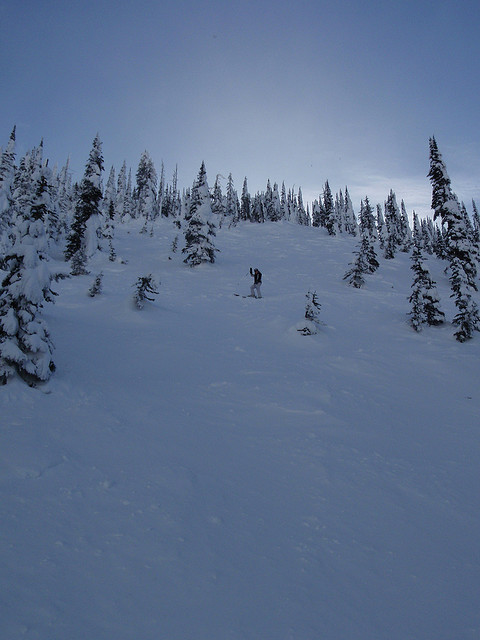What are the implications of snowboarding in such dense wooded areas from an environmental perspective? Snowboarding in densely wooded areas requires responsible practices to minimize ecological impact. It's important to avoid damaging the undergrowth and to respect wildlife habitats. Sticking to existing trails and following 'Leave No Trace' principles can help preserve these pristine natural spaces. 